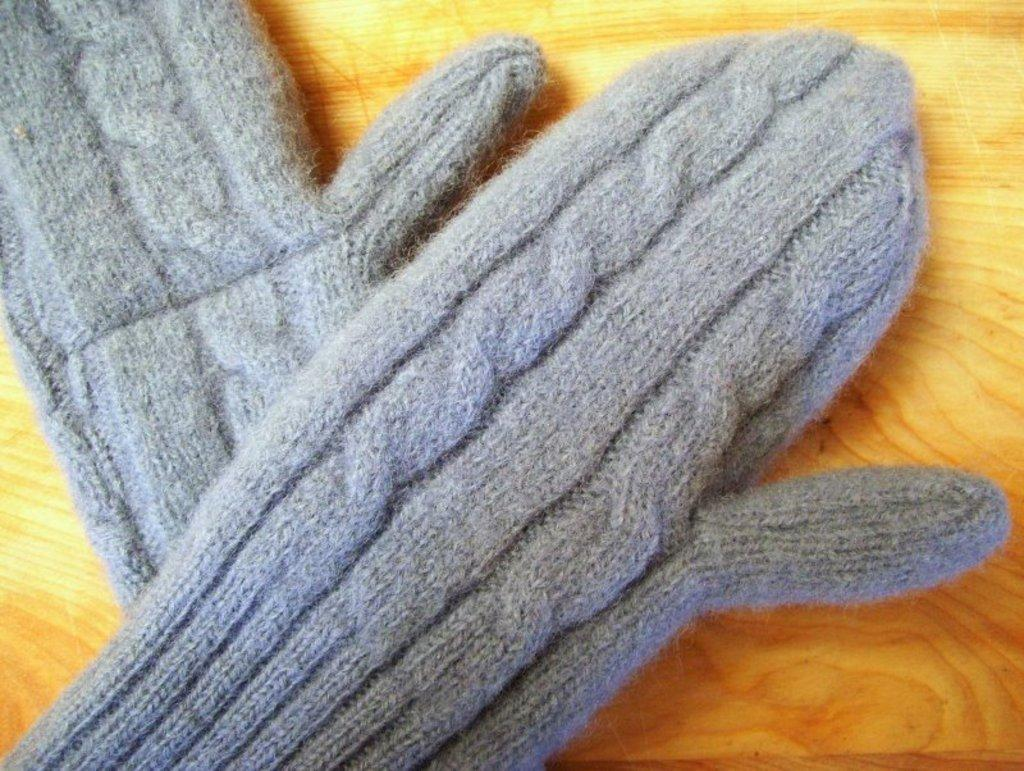What type of objects are present in the image? There are two hand gloves in the image. Where are the hand gloves located? The hand gloves are placed on a surface. What is the governor doing on the roof in the image? There is no governor or roof present in the image; it only features two hand gloves placed on a surface. 